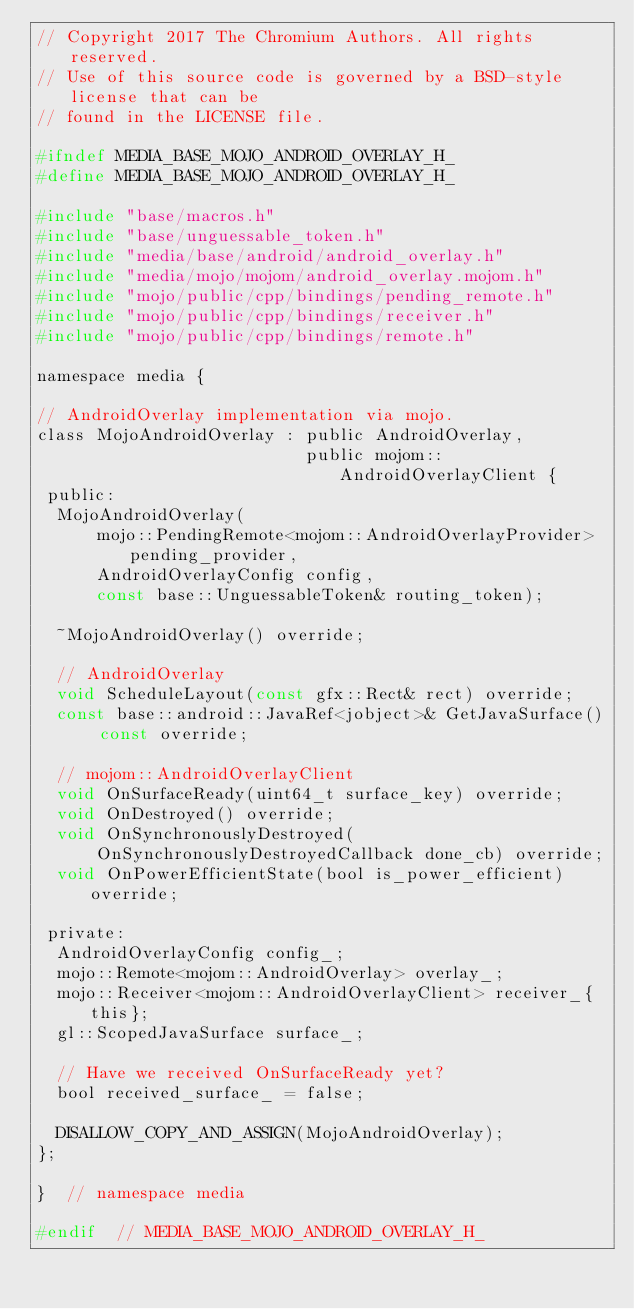Convert code to text. <code><loc_0><loc_0><loc_500><loc_500><_C_>// Copyright 2017 The Chromium Authors. All rights reserved.
// Use of this source code is governed by a BSD-style license that can be
// found in the LICENSE file.

#ifndef MEDIA_BASE_MOJO_ANDROID_OVERLAY_H_
#define MEDIA_BASE_MOJO_ANDROID_OVERLAY_H_

#include "base/macros.h"
#include "base/unguessable_token.h"
#include "media/base/android/android_overlay.h"
#include "media/mojo/mojom/android_overlay.mojom.h"
#include "mojo/public/cpp/bindings/pending_remote.h"
#include "mojo/public/cpp/bindings/receiver.h"
#include "mojo/public/cpp/bindings/remote.h"

namespace media {

// AndroidOverlay implementation via mojo.
class MojoAndroidOverlay : public AndroidOverlay,
                           public mojom::AndroidOverlayClient {
 public:
  MojoAndroidOverlay(
      mojo::PendingRemote<mojom::AndroidOverlayProvider> pending_provider,
      AndroidOverlayConfig config,
      const base::UnguessableToken& routing_token);

  ~MojoAndroidOverlay() override;

  // AndroidOverlay
  void ScheduleLayout(const gfx::Rect& rect) override;
  const base::android::JavaRef<jobject>& GetJavaSurface() const override;

  // mojom::AndroidOverlayClient
  void OnSurfaceReady(uint64_t surface_key) override;
  void OnDestroyed() override;
  void OnSynchronouslyDestroyed(
      OnSynchronouslyDestroyedCallback done_cb) override;
  void OnPowerEfficientState(bool is_power_efficient) override;

 private:
  AndroidOverlayConfig config_;
  mojo::Remote<mojom::AndroidOverlay> overlay_;
  mojo::Receiver<mojom::AndroidOverlayClient> receiver_{this};
  gl::ScopedJavaSurface surface_;

  // Have we received OnSurfaceReady yet?
  bool received_surface_ = false;

  DISALLOW_COPY_AND_ASSIGN(MojoAndroidOverlay);
};

}  // namespace media

#endif  // MEDIA_BASE_MOJO_ANDROID_OVERLAY_H_
</code> 